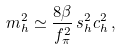Convert formula to latex. <formula><loc_0><loc_0><loc_500><loc_500>m _ { h } ^ { 2 } \simeq \frac { 8 \beta } { f ^ { 2 } _ { \pi } } \, s ^ { 2 } _ { h } c ^ { 2 } _ { h } \, ,</formula> 